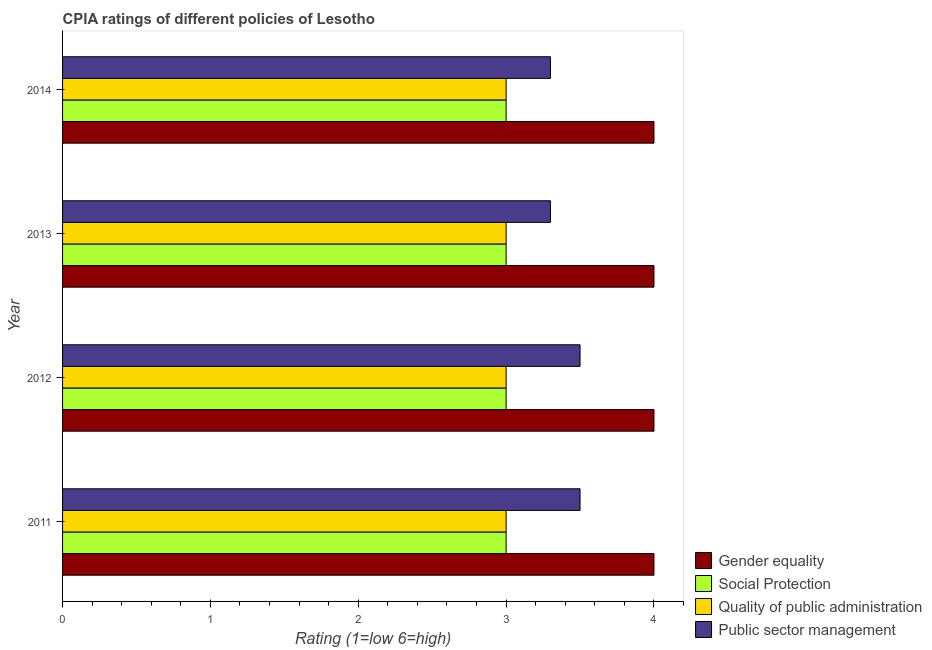How many different coloured bars are there?
Make the answer very short. 4. Are the number of bars per tick equal to the number of legend labels?
Give a very brief answer. Yes. What is the cpia rating of gender equality in 2014?
Provide a short and direct response. 4. Across all years, what is the minimum cpia rating of quality of public administration?
Keep it short and to the point. 3. In which year was the cpia rating of social protection minimum?
Provide a short and direct response. 2011. What is the total cpia rating of quality of public administration in the graph?
Your answer should be very brief. 12. What is the difference between the cpia rating of public sector management in 2011 and that in 2012?
Offer a very short reply. 0. What is the ratio of the cpia rating of public sector management in 2012 to that in 2013?
Your answer should be compact. 1.06. Is the cpia rating of public sector management in 2011 less than that in 2013?
Provide a succinct answer. No. Is the difference between the cpia rating of social protection in 2013 and 2014 greater than the difference between the cpia rating of public sector management in 2013 and 2014?
Offer a terse response. No. What is the difference between the highest and the lowest cpia rating of quality of public administration?
Give a very brief answer. 0. Is it the case that in every year, the sum of the cpia rating of public sector management and cpia rating of gender equality is greater than the sum of cpia rating of social protection and cpia rating of quality of public administration?
Keep it short and to the point. Yes. What does the 3rd bar from the top in 2011 represents?
Your answer should be very brief. Social Protection. What does the 1st bar from the bottom in 2014 represents?
Provide a short and direct response. Gender equality. Are all the bars in the graph horizontal?
Provide a short and direct response. Yes. Are the values on the major ticks of X-axis written in scientific E-notation?
Provide a short and direct response. No. Does the graph contain any zero values?
Offer a very short reply. No. Where does the legend appear in the graph?
Your answer should be very brief. Bottom right. How many legend labels are there?
Provide a short and direct response. 4. What is the title of the graph?
Give a very brief answer. CPIA ratings of different policies of Lesotho. What is the label or title of the X-axis?
Your answer should be compact. Rating (1=low 6=high). What is the Rating (1=low 6=high) in Gender equality in 2011?
Keep it short and to the point. 4. What is the Rating (1=low 6=high) in Quality of public administration in 2011?
Ensure brevity in your answer.  3. What is the Rating (1=low 6=high) in Public sector management in 2011?
Keep it short and to the point. 3.5. What is the Rating (1=low 6=high) in Social Protection in 2012?
Your answer should be compact. 3. What is the Rating (1=low 6=high) in Public sector management in 2012?
Your response must be concise. 3.5. What is the Rating (1=low 6=high) of Social Protection in 2013?
Provide a succinct answer. 3. What is the Rating (1=low 6=high) of Quality of public administration in 2013?
Keep it short and to the point. 3. What is the Rating (1=low 6=high) of Public sector management in 2013?
Your answer should be very brief. 3.3. What is the Rating (1=low 6=high) in Quality of public administration in 2014?
Offer a terse response. 3. Across all years, what is the maximum Rating (1=low 6=high) in Public sector management?
Provide a succinct answer. 3.5. Across all years, what is the minimum Rating (1=low 6=high) in Gender equality?
Your response must be concise. 4. Across all years, what is the minimum Rating (1=low 6=high) in Public sector management?
Make the answer very short. 3.3. What is the total Rating (1=low 6=high) of Gender equality in the graph?
Give a very brief answer. 16. What is the total Rating (1=low 6=high) in Public sector management in the graph?
Ensure brevity in your answer.  13.6. What is the difference between the Rating (1=low 6=high) of Gender equality in 2011 and that in 2012?
Ensure brevity in your answer.  0. What is the difference between the Rating (1=low 6=high) of Social Protection in 2011 and that in 2012?
Provide a short and direct response. 0. What is the difference between the Rating (1=low 6=high) in Public sector management in 2011 and that in 2012?
Provide a short and direct response. 0. What is the difference between the Rating (1=low 6=high) of Gender equality in 2011 and that in 2013?
Make the answer very short. 0. What is the difference between the Rating (1=low 6=high) of Social Protection in 2011 and that in 2013?
Offer a very short reply. 0. What is the difference between the Rating (1=low 6=high) in Quality of public administration in 2011 and that in 2013?
Keep it short and to the point. 0. What is the difference between the Rating (1=low 6=high) of Public sector management in 2011 and that in 2013?
Provide a succinct answer. 0.2. What is the difference between the Rating (1=low 6=high) of Gender equality in 2011 and that in 2014?
Your answer should be very brief. 0. What is the difference between the Rating (1=low 6=high) of Quality of public administration in 2011 and that in 2014?
Make the answer very short. 0. What is the difference between the Rating (1=low 6=high) in Public sector management in 2011 and that in 2014?
Offer a terse response. 0.2. What is the difference between the Rating (1=low 6=high) of Gender equality in 2012 and that in 2013?
Ensure brevity in your answer.  0. What is the difference between the Rating (1=low 6=high) of Quality of public administration in 2012 and that in 2013?
Give a very brief answer. 0. What is the difference between the Rating (1=low 6=high) of Public sector management in 2012 and that in 2013?
Your answer should be compact. 0.2. What is the difference between the Rating (1=low 6=high) in Quality of public administration in 2012 and that in 2014?
Your response must be concise. 0. What is the difference between the Rating (1=low 6=high) of Social Protection in 2013 and that in 2014?
Make the answer very short. 0. What is the difference between the Rating (1=low 6=high) in Quality of public administration in 2013 and that in 2014?
Provide a succinct answer. 0. What is the difference between the Rating (1=low 6=high) of Public sector management in 2013 and that in 2014?
Give a very brief answer. 0. What is the difference between the Rating (1=low 6=high) in Gender equality in 2011 and the Rating (1=low 6=high) in Social Protection in 2012?
Your response must be concise. 1. What is the difference between the Rating (1=low 6=high) of Social Protection in 2011 and the Rating (1=low 6=high) of Quality of public administration in 2012?
Your answer should be compact. 0. What is the difference between the Rating (1=low 6=high) of Quality of public administration in 2011 and the Rating (1=low 6=high) of Public sector management in 2012?
Offer a terse response. -0.5. What is the difference between the Rating (1=low 6=high) of Gender equality in 2011 and the Rating (1=low 6=high) of Public sector management in 2013?
Keep it short and to the point. 0.7. What is the difference between the Rating (1=low 6=high) in Social Protection in 2011 and the Rating (1=low 6=high) in Quality of public administration in 2013?
Your answer should be very brief. 0. What is the difference between the Rating (1=low 6=high) of Quality of public administration in 2011 and the Rating (1=low 6=high) of Public sector management in 2013?
Your answer should be very brief. -0.3. What is the difference between the Rating (1=low 6=high) in Gender equality in 2011 and the Rating (1=low 6=high) in Quality of public administration in 2014?
Your response must be concise. 1. What is the difference between the Rating (1=low 6=high) of Gender equality in 2011 and the Rating (1=low 6=high) of Public sector management in 2014?
Offer a very short reply. 0.7. What is the difference between the Rating (1=low 6=high) of Social Protection in 2011 and the Rating (1=low 6=high) of Public sector management in 2014?
Your answer should be compact. -0.3. What is the difference between the Rating (1=low 6=high) in Quality of public administration in 2011 and the Rating (1=low 6=high) in Public sector management in 2014?
Provide a succinct answer. -0.3. What is the difference between the Rating (1=low 6=high) of Gender equality in 2012 and the Rating (1=low 6=high) of Social Protection in 2013?
Make the answer very short. 1. What is the difference between the Rating (1=low 6=high) of Social Protection in 2012 and the Rating (1=low 6=high) of Quality of public administration in 2013?
Provide a short and direct response. 0. What is the difference between the Rating (1=low 6=high) of Social Protection in 2012 and the Rating (1=low 6=high) of Public sector management in 2013?
Make the answer very short. -0.3. What is the difference between the Rating (1=low 6=high) in Quality of public administration in 2012 and the Rating (1=low 6=high) in Public sector management in 2013?
Your response must be concise. -0.3. What is the difference between the Rating (1=low 6=high) in Gender equality in 2012 and the Rating (1=low 6=high) in Social Protection in 2014?
Your response must be concise. 1. What is the difference between the Rating (1=low 6=high) in Gender equality in 2012 and the Rating (1=low 6=high) in Public sector management in 2014?
Offer a very short reply. 0.7. What is the difference between the Rating (1=low 6=high) of Social Protection in 2012 and the Rating (1=low 6=high) of Quality of public administration in 2014?
Your answer should be compact. 0. What is the difference between the Rating (1=low 6=high) of Social Protection in 2012 and the Rating (1=low 6=high) of Public sector management in 2014?
Offer a terse response. -0.3. What is the difference between the Rating (1=low 6=high) of Gender equality in 2013 and the Rating (1=low 6=high) of Quality of public administration in 2014?
Keep it short and to the point. 1. What is the difference between the Rating (1=low 6=high) in Gender equality in 2013 and the Rating (1=low 6=high) in Public sector management in 2014?
Provide a short and direct response. 0.7. What is the difference between the Rating (1=low 6=high) of Social Protection in 2013 and the Rating (1=low 6=high) of Public sector management in 2014?
Your answer should be compact. -0.3. What is the average Rating (1=low 6=high) of Social Protection per year?
Provide a succinct answer. 3. What is the average Rating (1=low 6=high) in Quality of public administration per year?
Your response must be concise. 3. In the year 2011, what is the difference between the Rating (1=low 6=high) in Gender equality and Rating (1=low 6=high) in Social Protection?
Offer a very short reply. 1. In the year 2012, what is the difference between the Rating (1=low 6=high) of Gender equality and Rating (1=low 6=high) of Social Protection?
Make the answer very short. 1. In the year 2012, what is the difference between the Rating (1=low 6=high) in Gender equality and Rating (1=low 6=high) in Quality of public administration?
Offer a very short reply. 1. In the year 2013, what is the difference between the Rating (1=low 6=high) of Gender equality and Rating (1=low 6=high) of Quality of public administration?
Make the answer very short. 1. In the year 2013, what is the difference between the Rating (1=low 6=high) of Social Protection and Rating (1=low 6=high) of Quality of public administration?
Give a very brief answer. 0. In the year 2013, what is the difference between the Rating (1=low 6=high) of Quality of public administration and Rating (1=low 6=high) of Public sector management?
Offer a very short reply. -0.3. In the year 2014, what is the difference between the Rating (1=low 6=high) of Gender equality and Rating (1=low 6=high) of Public sector management?
Give a very brief answer. 0.7. In the year 2014, what is the difference between the Rating (1=low 6=high) in Social Protection and Rating (1=low 6=high) in Quality of public administration?
Provide a succinct answer. 0. In the year 2014, what is the difference between the Rating (1=low 6=high) of Social Protection and Rating (1=low 6=high) of Public sector management?
Your answer should be compact. -0.3. In the year 2014, what is the difference between the Rating (1=low 6=high) of Quality of public administration and Rating (1=low 6=high) of Public sector management?
Your response must be concise. -0.3. What is the ratio of the Rating (1=low 6=high) of Quality of public administration in 2011 to that in 2012?
Give a very brief answer. 1. What is the ratio of the Rating (1=low 6=high) of Social Protection in 2011 to that in 2013?
Your answer should be compact. 1. What is the ratio of the Rating (1=low 6=high) in Public sector management in 2011 to that in 2013?
Provide a succinct answer. 1.06. What is the ratio of the Rating (1=low 6=high) in Gender equality in 2011 to that in 2014?
Give a very brief answer. 1. What is the ratio of the Rating (1=low 6=high) of Quality of public administration in 2011 to that in 2014?
Your answer should be compact. 1. What is the ratio of the Rating (1=low 6=high) in Public sector management in 2011 to that in 2014?
Offer a terse response. 1.06. What is the ratio of the Rating (1=low 6=high) of Gender equality in 2012 to that in 2013?
Keep it short and to the point. 1. What is the ratio of the Rating (1=low 6=high) in Social Protection in 2012 to that in 2013?
Provide a succinct answer. 1. What is the ratio of the Rating (1=low 6=high) in Public sector management in 2012 to that in 2013?
Your answer should be very brief. 1.06. What is the ratio of the Rating (1=low 6=high) of Gender equality in 2012 to that in 2014?
Keep it short and to the point. 1. What is the ratio of the Rating (1=low 6=high) of Social Protection in 2012 to that in 2014?
Ensure brevity in your answer.  1. What is the ratio of the Rating (1=low 6=high) of Public sector management in 2012 to that in 2014?
Offer a very short reply. 1.06. What is the ratio of the Rating (1=low 6=high) of Quality of public administration in 2013 to that in 2014?
Make the answer very short. 1. What is the difference between the highest and the second highest Rating (1=low 6=high) in Social Protection?
Ensure brevity in your answer.  0. What is the difference between the highest and the second highest Rating (1=low 6=high) of Quality of public administration?
Keep it short and to the point. 0. What is the difference between the highest and the lowest Rating (1=low 6=high) of Gender equality?
Your answer should be compact. 0. What is the difference between the highest and the lowest Rating (1=low 6=high) of Social Protection?
Offer a very short reply. 0. What is the difference between the highest and the lowest Rating (1=low 6=high) in Quality of public administration?
Your response must be concise. 0. What is the difference between the highest and the lowest Rating (1=low 6=high) in Public sector management?
Keep it short and to the point. 0.2. 